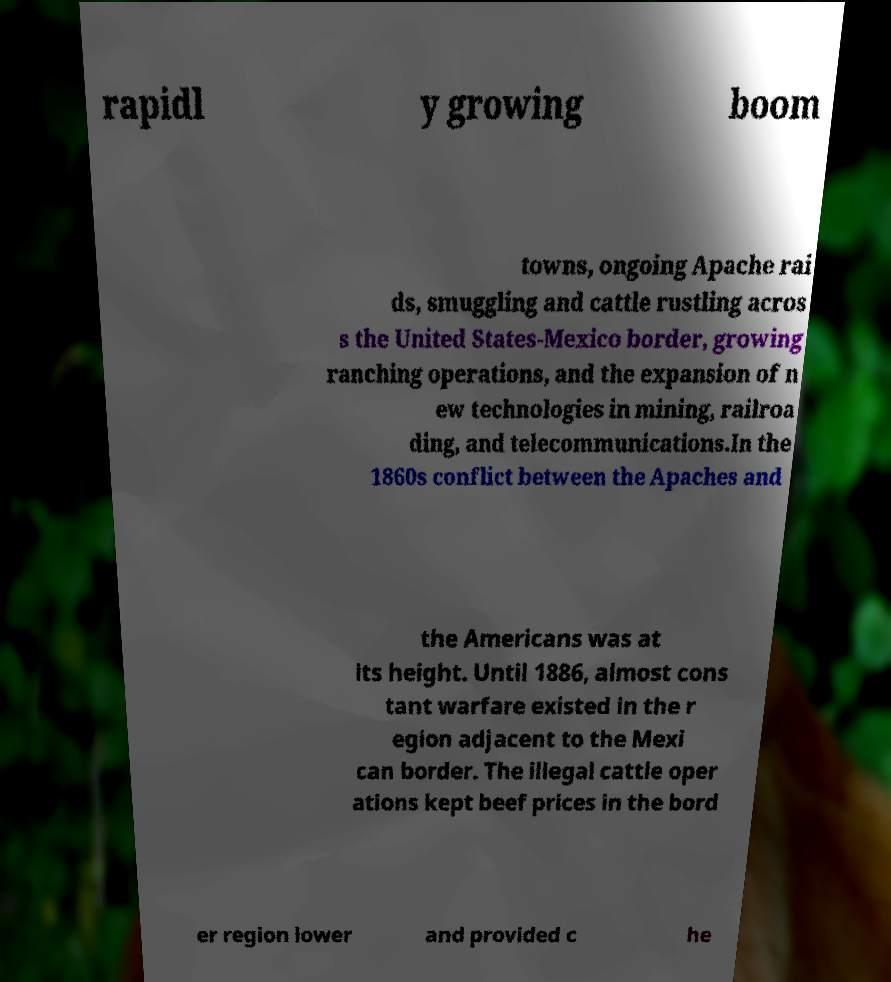Can you read and provide the text displayed in the image?This photo seems to have some interesting text. Can you extract and type it out for me? rapidl y growing boom towns, ongoing Apache rai ds, smuggling and cattle rustling acros s the United States-Mexico border, growing ranching operations, and the expansion of n ew technologies in mining, railroa ding, and telecommunications.In the 1860s conflict between the Apaches and the Americans was at its height. Until 1886, almost cons tant warfare existed in the r egion adjacent to the Mexi can border. The illegal cattle oper ations kept beef prices in the bord er region lower and provided c he 